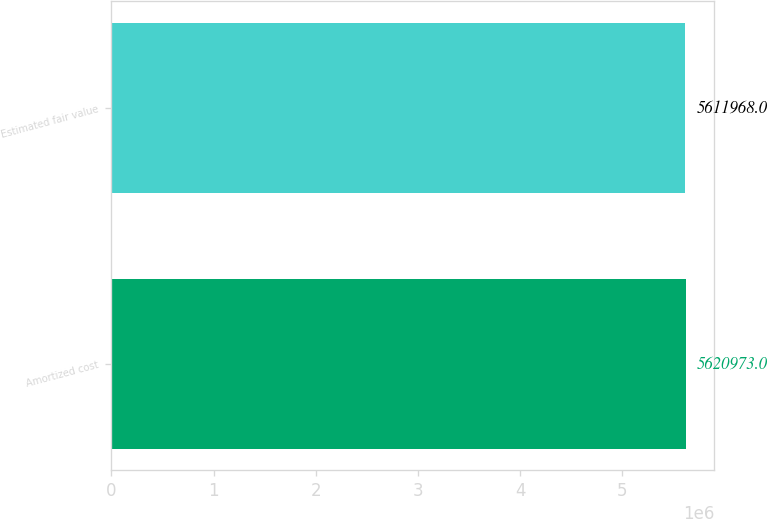<chart> <loc_0><loc_0><loc_500><loc_500><bar_chart><fcel>Amortized cost<fcel>Estimated fair value<nl><fcel>5.62097e+06<fcel>5.61197e+06<nl></chart> 